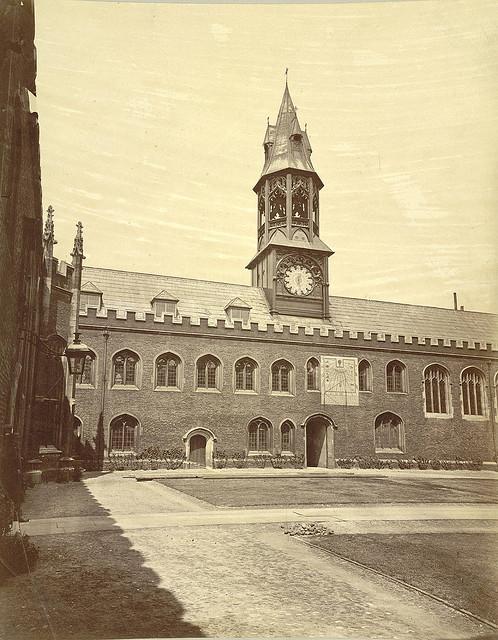How many windows are on the building?
Keep it brief. 15. Is this a church?
Concise answer only. Yes. Is this an old picture?
Answer briefly. Yes. How many doors are there?
Give a very brief answer. 2. 